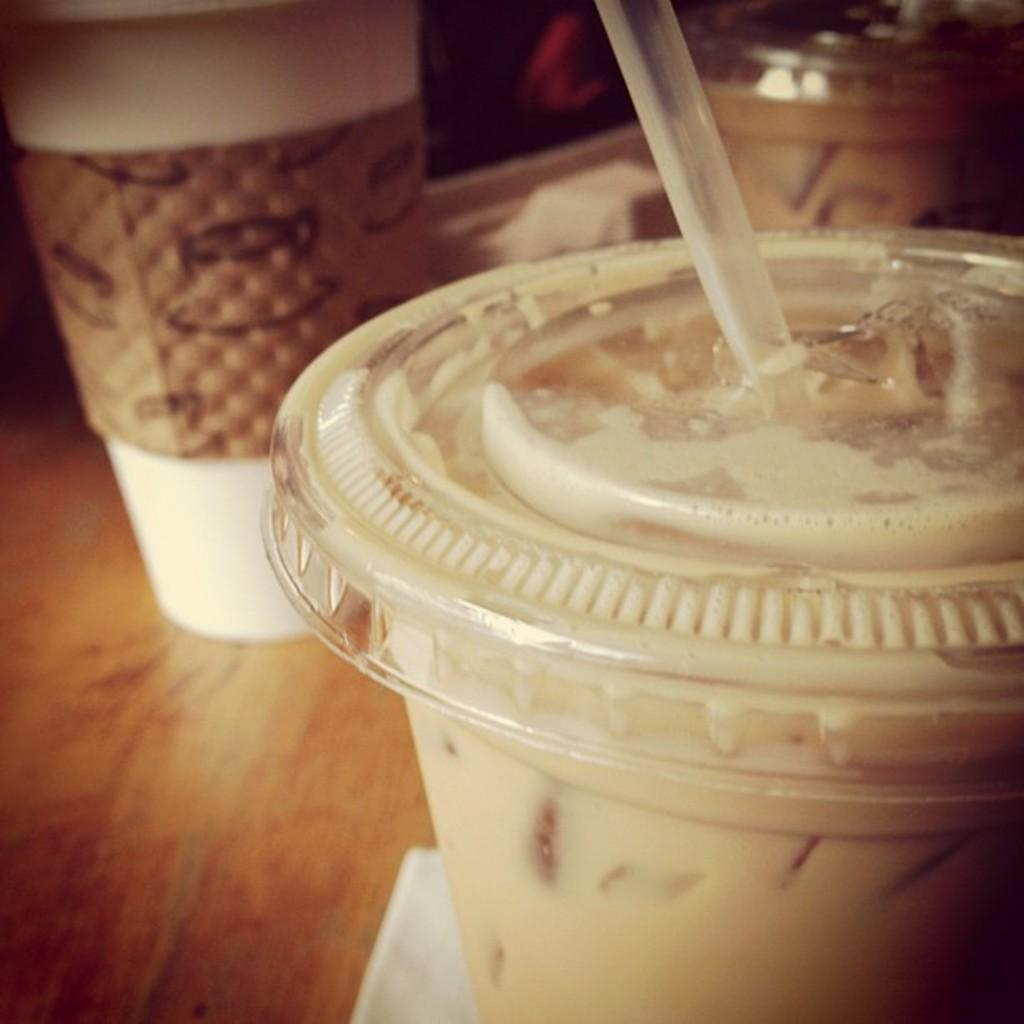What objects are present in the image that can be used for drinking? There are cups in the image that can be used for drinking. What is the additional object that can be used with the cups? There is a straw in the image that can be used with the cups. What can be seen in the background of the image? There are vessels in the background of the image. What type of ray can be seen swimming in the background of the image? There is no ray present in the image; it only features cups, a straw, and vessels in the background. 